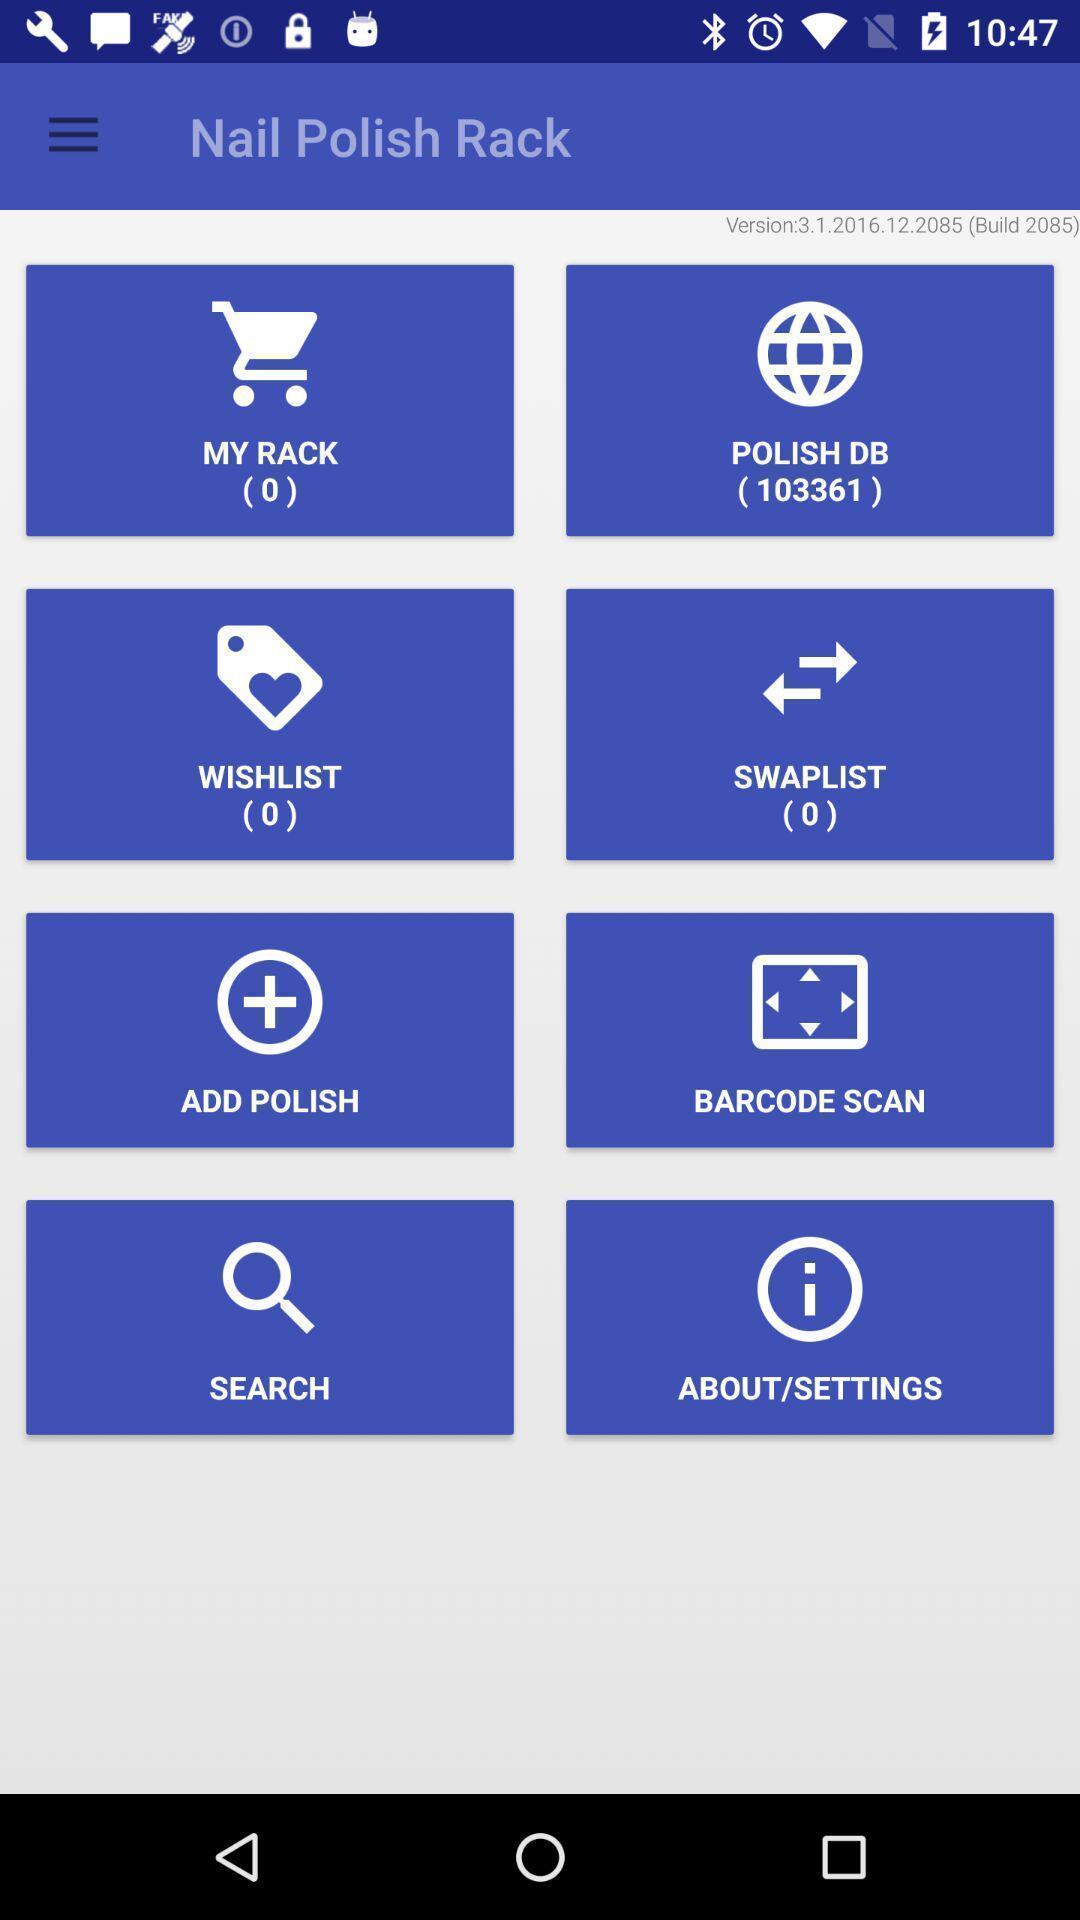Tell me what you see in this picture. Various tools in a nail polish rack app. 